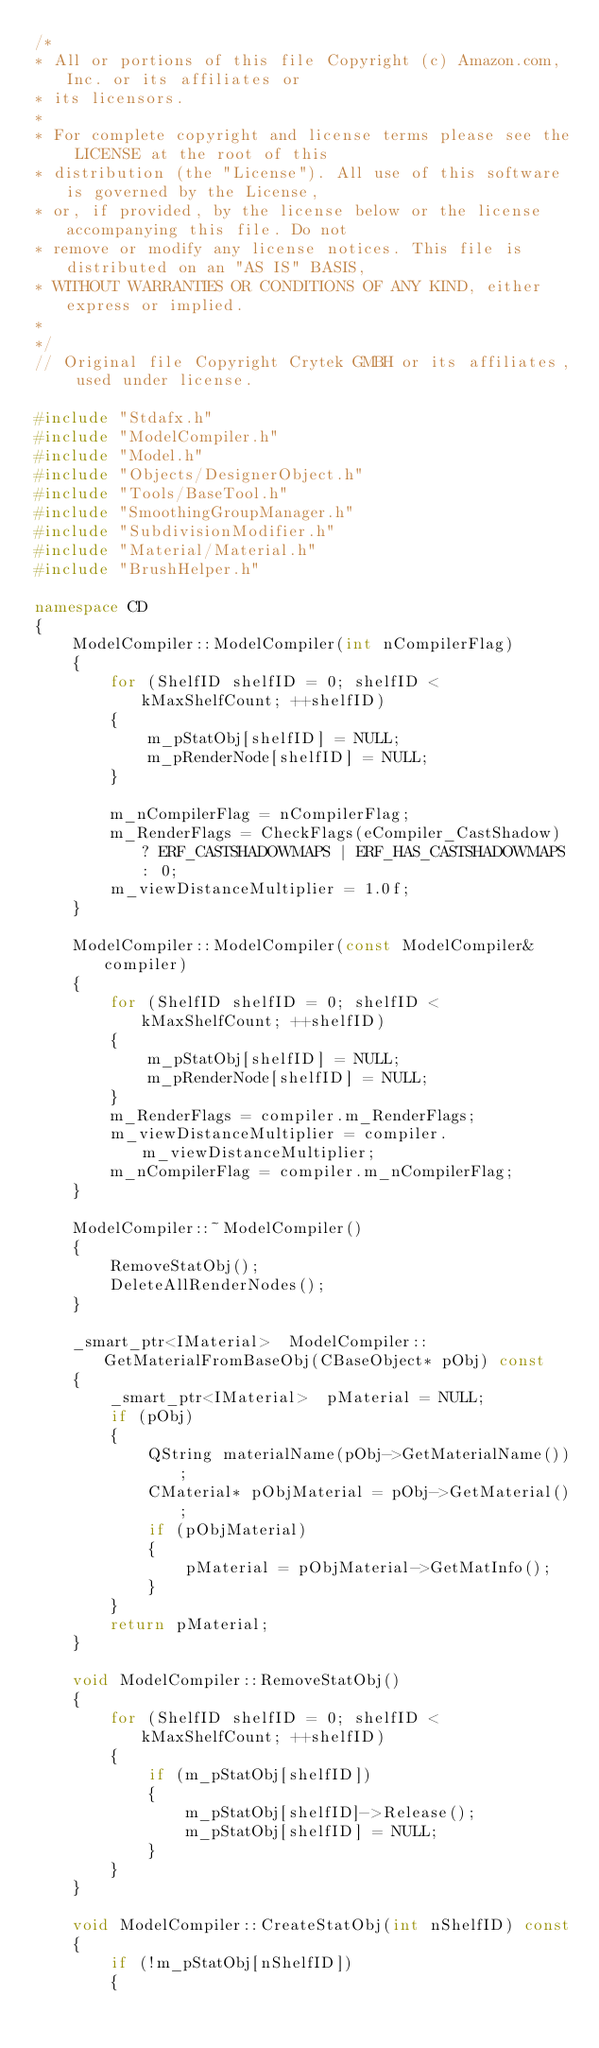Convert code to text. <code><loc_0><loc_0><loc_500><loc_500><_C++_>/*
* All or portions of this file Copyright (c) Amazon.com, Inc. or its affiliates or
* its licensors.
*
* For complete copyright and license terms please see the LICENSE at the root of this
* distribution (the "License"). All use of this software is governed by the License,
* or, if provided, by the license below or the license accompanying this file. Do not
* remove or modify any license notices. This file is distributed on an "AS IS" BASIS,
* WITHOUT WARRANTIES OR CONDITIONS OF ANY KIND, either express or implied.
*
*/
// Original file Copyright Crytek GMBH or its affiliates, used under license.

#include "Stdafx.h"
#include "ModelCompiler.h"
#include "Model.h"
#include "Objects/DesignerObject.h"
#include "Tools/BaseTool.h"
#include "SmoothingGroupManager.h"
#include "SubdivisionModifier.h"
#include "Material/Material.h"
#include "BrushHelper.h"

namespace CD
{
    ModelCompiler::ModelCompiler(int nCompilerFlag)
    {
        for (ShelfID shelfID = 0; shelfID < kMaxShelfCount; ++shelfID)
        {
            m_pStatObj[shelfID] = NULL;
            m_pRenderNode[shelfID] = NULL;
        }

        m_nCompilerFlag = nCompilerFlag;
        m_RenderFlags = CheckFlags(eCompiler_CastShadow) ? ERF_CASTSHADOWMAPS | ERF_HAS_CASTSHADOWMAPS : 0;
        m_viewDistanceMultiplier = 1.0f;
    }

    ModelCompiler::ModelCompiler(const ModelCompiler& compiler)
    {
        for (ShelfID shelfID = 0; shelfID < kMaxShelfCount; ++shelfID)
        {
            m_pStatObj[shelfID] = NULL;
            m_pRenderNode[shelfID] = NULL;
        }
        m_RenderFlags = compiler.m_RenderFlags;
        m_viewDistanceMultiplier = compiler.m_viewDistanceMultiplier;
        m_nCompilerFlag = compiler.m_nCompilerFlag;
    }

    ModelCompiler::~ModelCompiler()
    {
        RemoveStatObj();
        DeleteAllRenderNodes();
    }

    _smart_ptr<IMaterial>  ModelCompiler::GetMaterialFromBaseObj(CBaseObject* pObj) const
    {
        _smart_ptr<IMaterial>  pMaterial = NULL;
        if (pObj)
        {
            QString materialName(pObj->GetMaterialName());
            CMaterial* pObjMaterial = pObj->GetMaterial();
            if (pObjMaterial)
            {
                pMaterial = pObjMaterial->GetMatInfo();
            }
        }
        return pMaterial;
    }

    void ModelCompiler::RemoveStatObj()
    {
        for (ShelfID shelfID = 0; shelfID < kMaxShelfCount; ++shelfID)
        {
            if (m_pStatObj[shelfID])
            {
                m_pStatObj[shelfID]->Release();
                m_pStatObj[shelfID] = NULL;
            }
        }
    }

    void ModelCompiler::CreateStatObj(int nShelfID) const
    {
        if (!m_pStatObj[nShelfID])
        {</code> 